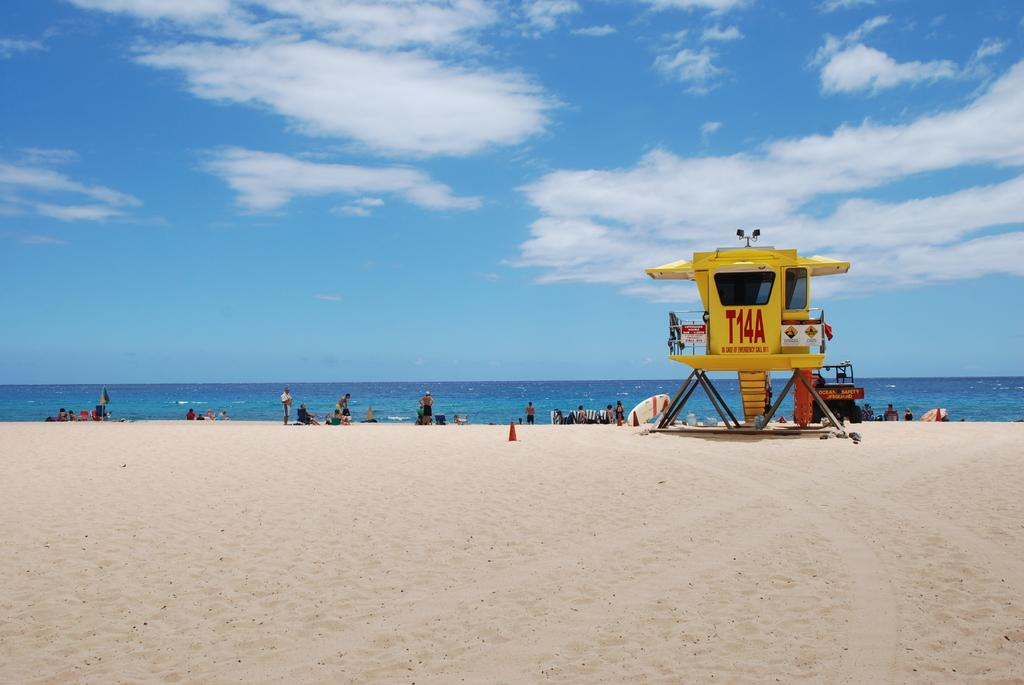<image>
Write a terse but informative summary of the picture. People at a beach on a nice day are being watched over by a lifeguard at station T14A. 